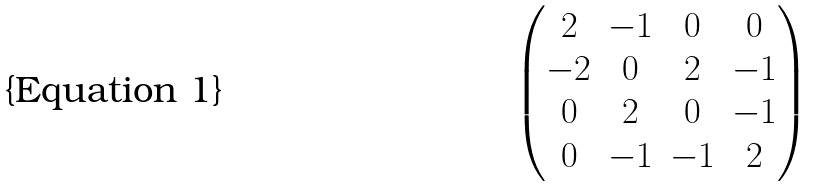Convert formula to latex. <formula><loc_0><loc_0><loc_500><loc_500>\begin{pmatrix} 2 & - 1 & 0 & 0 \\ - 2 & 0 & 2 & - 1 \\ 0 & 2 & 0 & - 1 \\ 0 & - 1 & - 1 & 2 \end{pmatrix}</formula> 